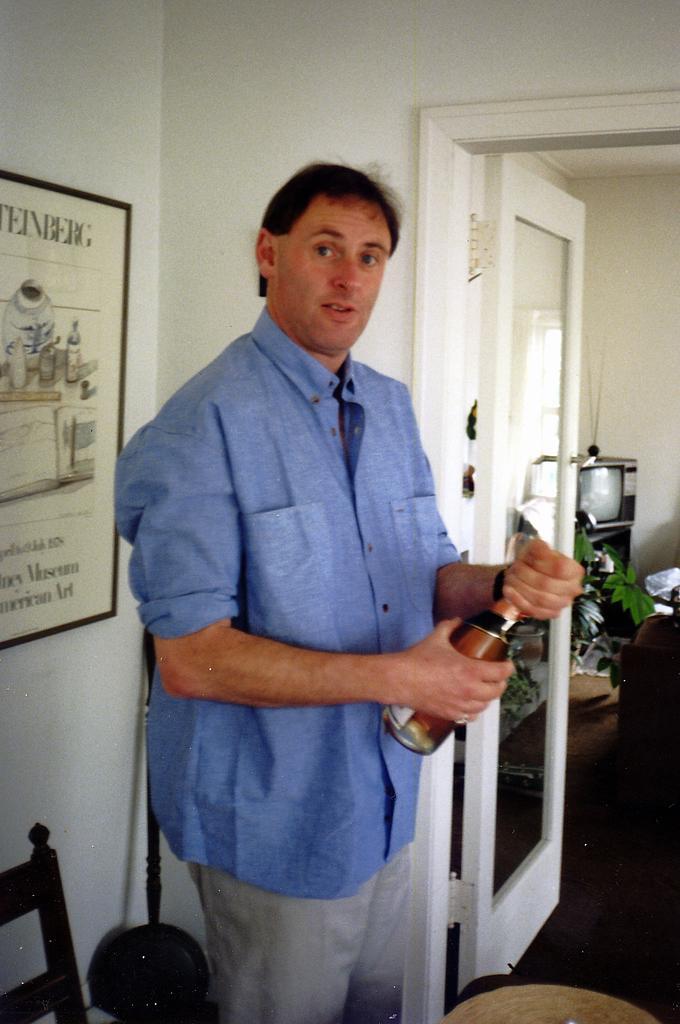In one or two sentences, can you explain what this image depicts? In this picture, we can see a person holding a bottle, and we can see the ground with some objects, and the wall with door, and some objects attached to it, and we can see some object in the bottom left corner. 